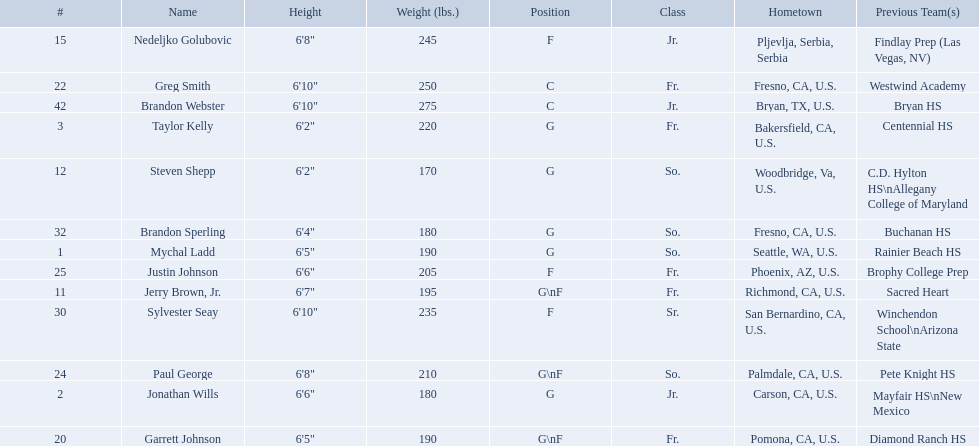Who played during the 2009-10 fresno state bulldogs men's basketball team? Mychal Ladd, Jonathan Wills, Taylor Kelly, Jerry Brown, Jr., Steven Shepp, Nedeljko Golubovic, Garrett Johnson, Greg Smith, Paul George, Justin Johnson, Sylvester Seay, Brandon Sperling, Brandon Webster. What was the position of each player? G, G, G, G\nF, G, F, G\nF, C, G\nF, F, F, G, C. And how tall were they? 6'5", 6'6", 6'2", 6'7", 6'2", 6'8", 6'5", 6'10", 6'8", 6'6", 6'10", 6'4", 6'10". Of these players, who was the shortest forward player? Justin Johnson. What are the names for all players? Mychal Ladd, Jonathan Wills, Taylor Kelly, Jerry Brown, Jr., Steven Shepp, Nedeljko Golubovic, Garrett Johnson, Greg Smith, Paul George, Justin Johnson, Sylvester Seay, Brandon Sperling, Brandon Webster. Which players are taller than 6'8? Nedeljko Golubovic, Greg Smith, Paul George, Sylvester Seay, Brandon Webster. How tall is paul george? 6'8". How tall is greg smith? 6'10". Of these two, which it tallest? Greg Smith. 